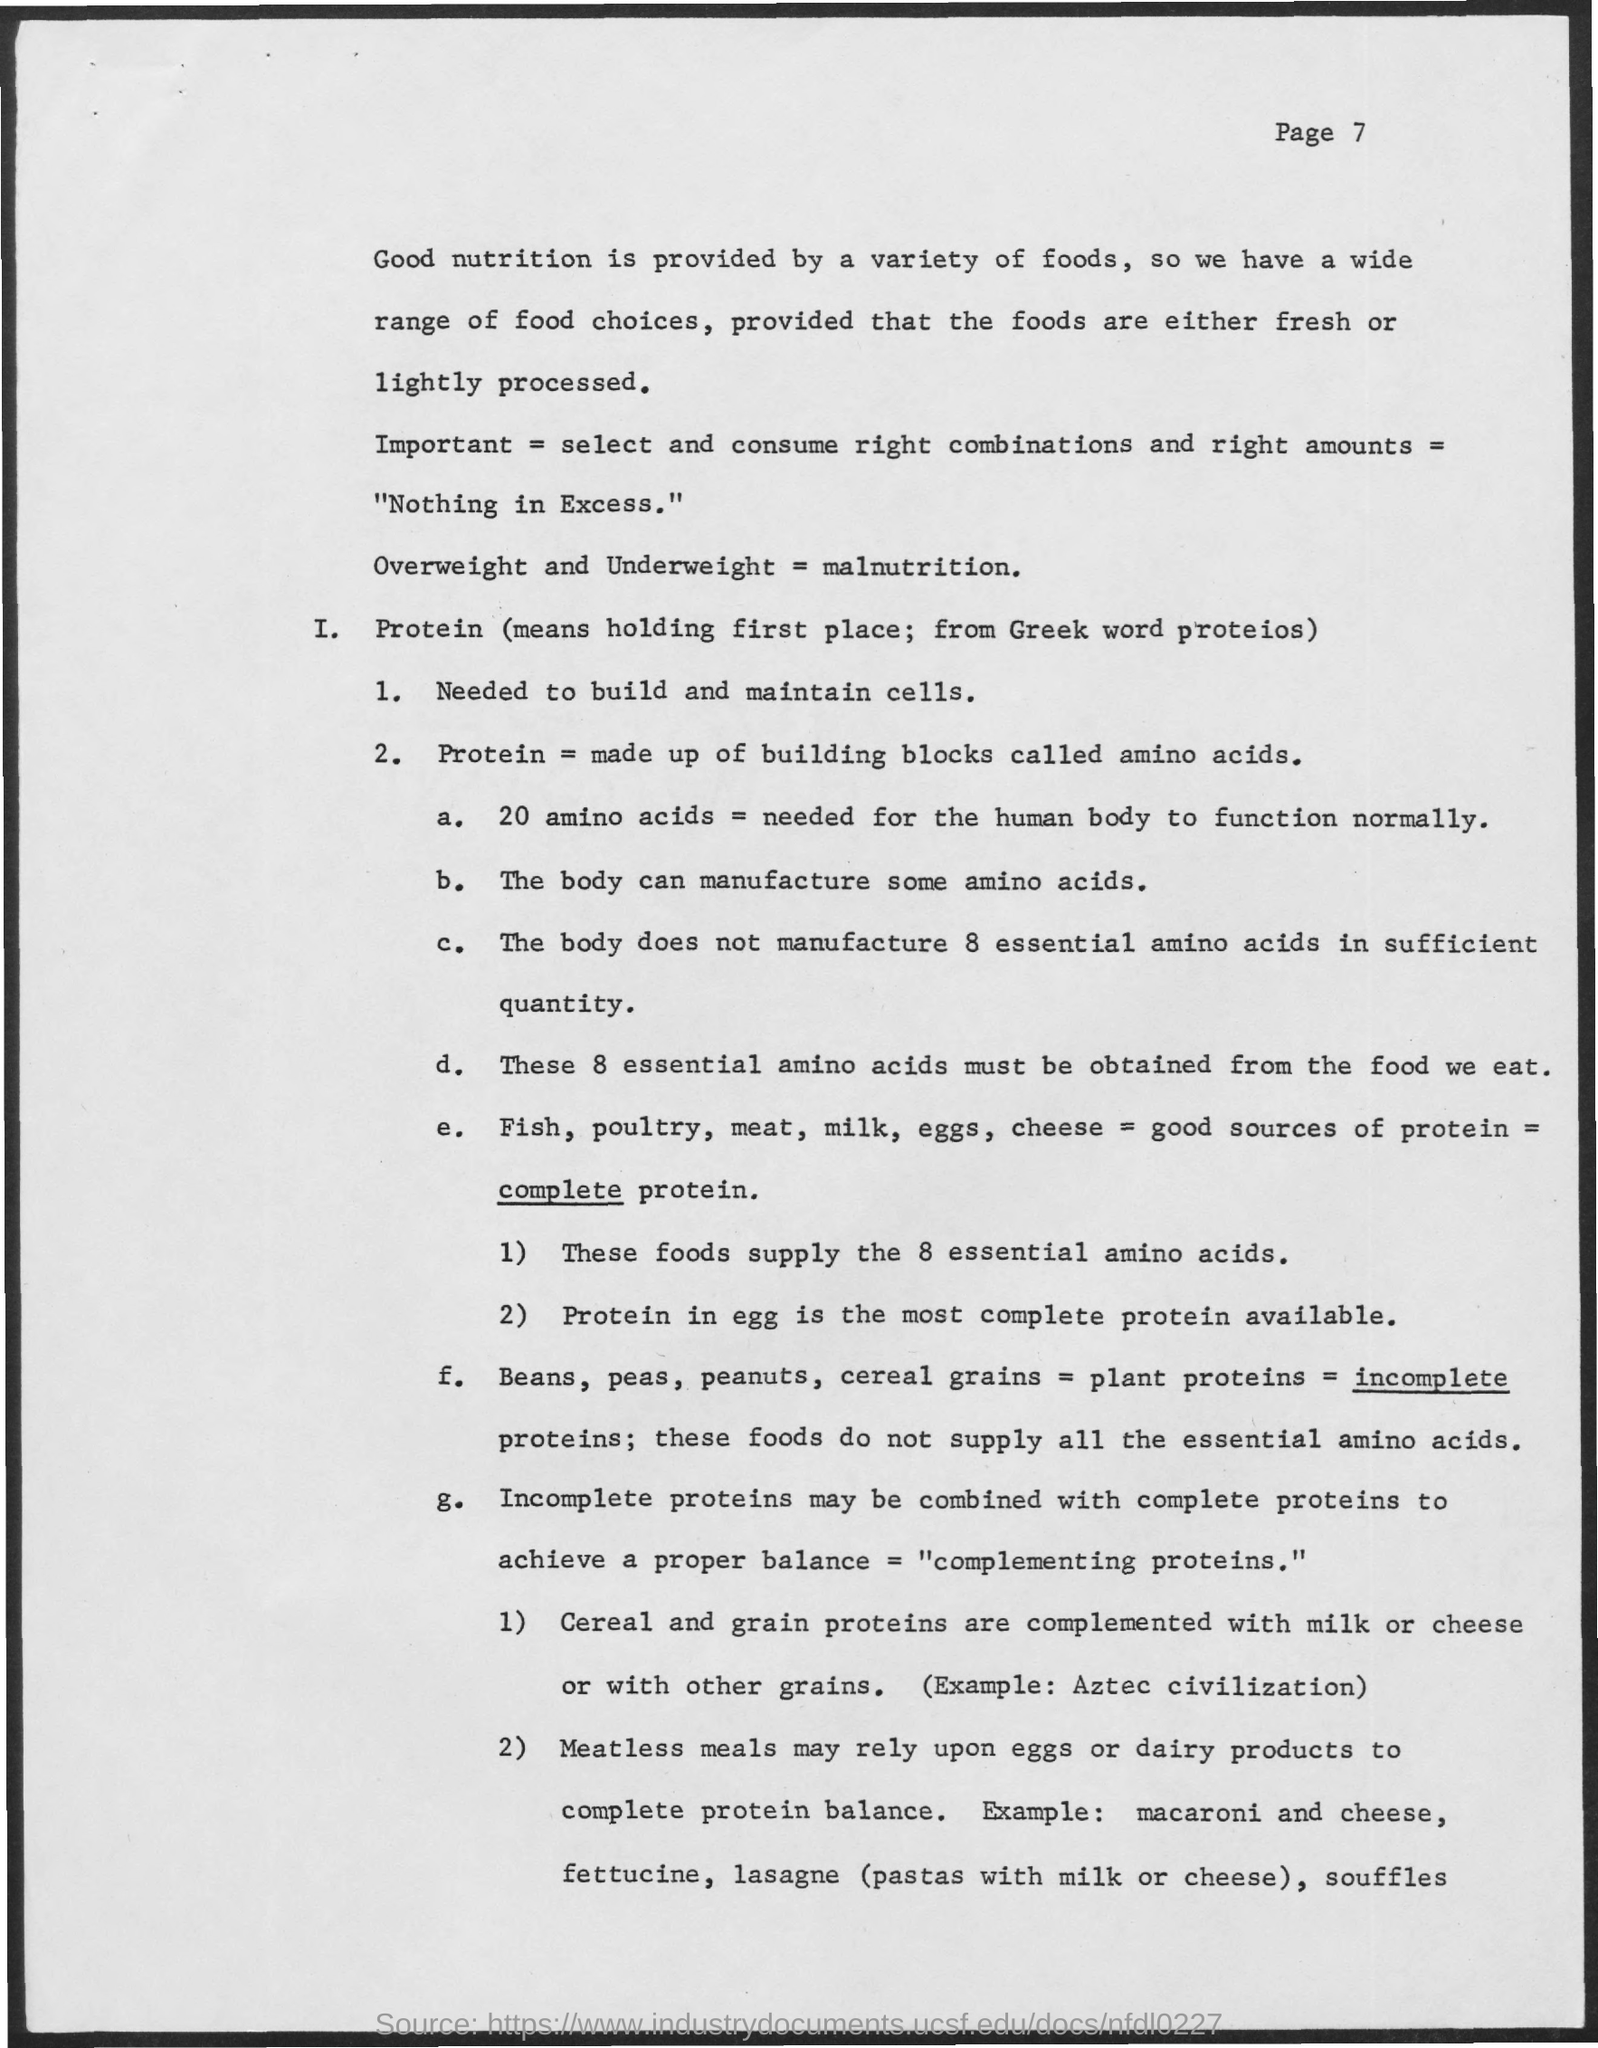Specify some key components in this picture. Plant proteins are referred to as incomplete proteins because they lack certain essential amino acids that are necessary for human health. These proteins are considered incomplete because they cannot provide all of the necessary amino acids for the body to function properly. Proteins are necessary for the construction and maintenance of cells. 